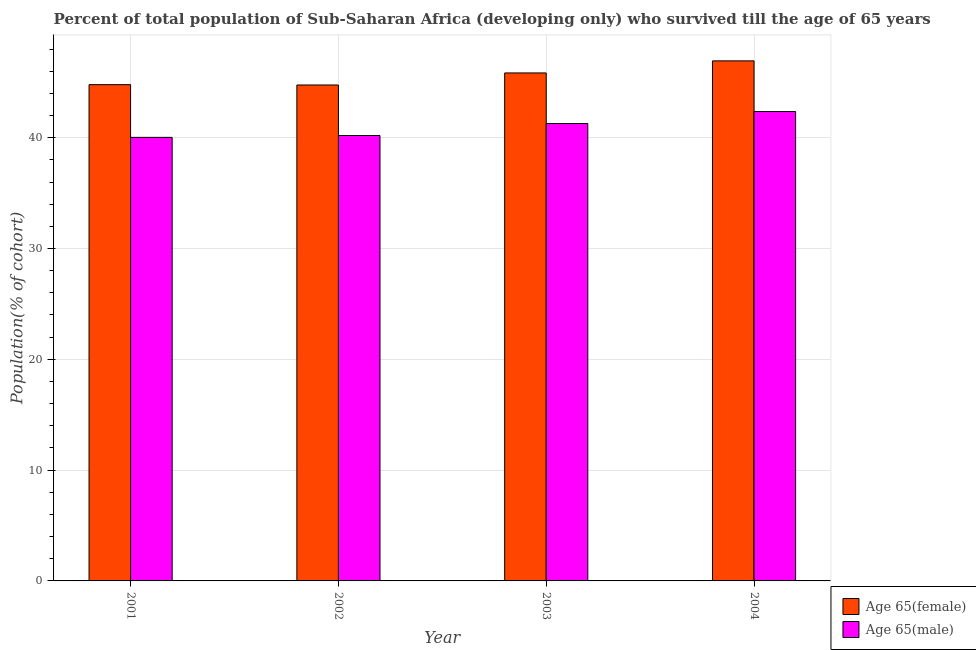Are the number of bars on each tick of the X-axis equal?
Offer a very short reply. Yes. How many bars are there on the 3rd tick from the left?
Your answer should be compact. 2. How many bars are there on the 4th tick from the right?
Your answer should be compact. 2. What is the label of the 4th group of bars from the left?
Offer a terse response. 2004. What is the percentage of female population who survived till age of 65 in 2004?
Provide a short and direct response. 46.93. Across all years, what is the maximum percentage of female population who survived till age of 65?
Offer a terse response. 46.93. Across all years, what is the minimum percentage of male population who survived till age of 65?
Your answer should be very brief. 40.03. What is the total percentage of female population who survived till age of 65 in the graph?
Offer a terse response. 182.32. What is the difference between the percentage of female population who survived till age of 65 in 2003 and that in 2004?
Make the answer very short. -1.09. What is the difference between the percentage of female population who survived till age of 65 in 2003 and the percentage of male population who survived till age of 65 in 2004?
Provide a short and direct response. -1.09. What is the average percentage of female population who survived till age of 65 per year?
Your answer should be compact. 45.58. In the year 2003, what is the difference between the percentage of female population who survived till age of 65 and percentage of male population who survived till age of 65?
Keep it short and to the point. 0. In how many years, is the percentage of male population who survived till age of 65 greater than 10 %?
Your answer should be very brief. 4. What is the ratio of the percentage of male population who survived till age of 65 in 2003 to that in 2004?
Provide a succinct answer. 0.97. Is the difference between the percentage of male population who survived till age of 65 in 2003 and 2004 greater than the difference between the percentage of female population who survived till age of 65 in 2003 and 2004?
Provide a succinct answer. No. What is the difference between the highest and the second highest percentage of male population who survived till age of 65?
Your response must be concise. 1.08. What is the difference between the highest and the lowest percentage of male population who survived till age of 65?
Provide a short and direct response. 2.33. Is the sum of the percentage of female population who survived till age of 65 in 2002 and 2004 greater than the maximum percentage of male population who survived till age of 65 across all years?
Provide a short and direct response. Yes. What does the 2nd bar from the left in 2004 represents?
Your answer should be compact. Age 65(male). What does the 2nd bar from the right in 2003 represents?
Your answer should be very brief. Age 65(female). How many years are there in the graph?
Your response must be concise. 4. Are the values on the major ticks of Y-axis written in scientific E-notation?
Your answer should be compact. No. Does the graph contain grids?
Provide a short and direct response. Yes. Where does the legend appear in the graph?
Your answer should be very brief. Bottom right. How are the legend labels stacked?
Give a very brief answer. Vertical. What is the title of the graph?
Your response must be concise. Percent of total population of Sub-Saharan Africa (developing only) who survived till the age of 65 years. What is the label or title of the Y-axis?
Ensure brevity in your answer.  Population(% of cohort). What is the Population(% of cohort) in Age 65(female) in 2001?
Your response must be concise. 44.79. What is the Population(% of cohort) in Age 65(male) in 2001?
Your answer should be compact. 40.03. What is the Population(% of cohort) of Age 65(female) in 2002?
Keep it short and to the point. 44.76. What is the Population(% of cohort) in Age 65(male) in 2002?
Your answer should be very brief. 40.2. What is the Population(% of cohort) of Age 65(female) in 2003?
Your answer should be compact. 45.84. What is the Population(% of cohort) in Age 65(male) in 2003?
Offer a terse response. 41.28. What is the Population(% of cohort) in Age 65(female) in 2004?
Offer a very short reply. 46.93. What is the Population(% of cohort) in Age 65(male) in 2004?
Keep it short and to the point. 42.36. Across all years, what is the maximum Population(% of cohort) in Age 65(female)?
Provide a short and direct response. 46.93. Across all years, what is the maximum Population(% of cohort) of Age 65(male)?
Provide a succinct answer. 42.36. Across all years, what is the minimum Population(% of cohort) of Age 65(female)?
Provide a succinct answer. 44.76. Across all years, what is the minimum Population(% of cohort) in Age 65(male)?
Provide a short and direct response. 40.03. What is the total Population(% of cohort) in Age 65(female) in the graph?
Keep it short and to the point. 182.32. What is the total Population(% of cohort) of Age 65(male) in the graph?
Give a very brief answer. 163.87. What is the difference between the Population(% of cohort) in Age 65(female) in 2001 and that in 2002?
Provide a succinct answer. 0.03. What is the difference between the Population(% of cohort) in Age 65(male) in 2001 and that in 2002?
Ensure brevity in your answer.  -0.17. What is the difference between the Population(% of cohort) of Age 65(female) in 2001 and that in 2003?
Offer a very short reply. -1.06. What is the difference between the Population(% of cohort) in Age 65(male) in 2001 and that in 2003?
Your response must be concise. -1.25. What is the difference between the Population(% of cohort) of Age 65(female) in 2001 and that in 2004?
Your answer should be compact. -2.15. What is the difference between the Population(% of cohort) in Age 65(male) in 2001 and that in 2004?
Your response must be concise. -2.33. What is the difference between the Population(% of cohort) in Age 65(female) in 2002 and that in 2003?
Your answer should be very brief. -1.09. What is the difference between the Population(% of cohort) in Age 65(male) in 2002 and that in 2003?
Provide a succinct answer. -1.08. What is the difference between the Population(% of cohort) in Age 65(female) in 2002 and that in 2004?
Offer a very short reply. -2.18. What is the difference between the Population(% of cohort) in Age 65(male) in 2002 and that in 2004?
Your answer should be compact. -2.16. What is the difference between the Population(% of cohort) in Age 65(female) in 2003 and that in 2004?
Keep it short and to the point. -1.09. What is the difference between the Population(% of cohort) in Age 65(male) in 2003 and that in 2004?
Your answer should be very brief. -1.08. What is the difference between the Population(% of cohort) in Age 65(female) in 2001 and the Population(% of cohort) in Age 65(male) in 2002?
Offer a very short reply. 4.59. What is the difference between the Population(% of cohort) of Age 65(female) in 2001 and the Population(% of cohort) of Age 65(male) in 2003?
Your answer should be very brief. 3.51. What is the difference between the Population(% of cohort) of Age 65(female) in 2001 and the Population(% of cohort) of Age 65(male) in 2004?
Your response must be concise. 2.43. What is the difference between the Population(% of cohort) of Age 65(female) in 2002 and the Population(% of cohort) of Age 65(male) in 2003?
Your answer should be very brief. 3.48. What is the difference between the Population(% of cohort) of Age 65(female) in 2002 and the Population(% of cohort) of Age 65(male) in 2004?
Your answer should be very brief. 2.4. What is the difference between the Population(% of cohort) in Age 65(female) in 2003 and the Population(% of cohort) in Age 65(male) in 2004?
Provide a succinct answer. 3.48. What is the average Population(% of cohort) of Age 65(female) per year?
Offer a very short reply. 45.58. What is the average Population(% of cohort) in Age 65(male) per year?
Offer a terse response. 40.97. In the year 2001, what is the difference between the Population(% of cohort) in Age 65(female) and Population(% of cohort) in Age 65(male)?
Your answer should be compact. 4.76. In the year 2002, what is the difference between the Population(% of cohort) in Age 65(female) and Population(% of cohort) in Age 65(male)?
Provide a short and direct response. 4.56. In the year 2003, what is the difference between the Population(% of cohort) of Age 65(female) and Population(% of cohort) of Age 65(male)?
Your response must be concise. 4.57. In the year 2004, what is the difference between the Population(% of cohort) of Age 65(female) and Population(% of cohort) of Age 65(male)?
Your answer should be very brief. 4.57. What is the ratio of the Population(% of cohort) of Age 65(female) in 2001 to that in 2002?
Provide a succinct answer. 1. What is the ratio of the Population(% of cohort) of Age 65(male) in 2001 to that in 2002?
Give a very brief answer. 1. What is the ratio of the Population(% of cohort) in Age 65(male) in 2001 to that in 2003?
Give a very brief answer. 0.97. What is the ratio of the Population(% of cohort) of Age 65(female) in 2001 to that in 2004?
Offer a very short reply. 0.95. What is the ratio of the Population(% of cohort) in Age 65(male) in 2001 to that in 2004?
Provide a succinct answer. 0.94. What is the ratio of the Population(% of cohort) in Age 65(female) in 2002 to that in 2003?
Make the answer very short. 0.98. What is the ratio of the Population(% of cohort) in Age 65(male) in 2002 to that in 2003?
Keep it short and to the point. 0.97. What is the ratio of the Population(% of cohort) of Age 65(female) in 2002 to that in 2004?
Offer a very short reply. 0.95. What is the ratio of the Population(% of cohort) in Age 65(male) in 2002 to that in 2004?
Your answer should be compact. 0.95. What is the ratio of the Population(% of cohort) of Age 65(female) in 2003 to that in 2004?
Keep it short and to the point. 0.98. What is the ratio of the Population(% of cohort) in Age 65(male) in 2003 to that in 2004?
Provide a succinct answer. 0.97. What is the difference between the highest and the second highest Population(% of cohort) in Age 65(female)?
Your response must be concise. 1.09. What is the difference between the highest and the second highest Population(% of cohort) in Age 65(male)?
Your answer should be very brief. 1.08. What is the difference between the highest and the lowest Population(% of cohort) in Age 65(female)?
Ensure brevity in your answer.  2.18. What is the difference between the highest and the lowest Population(% of cohort) in Age 65(male)?
Provide a succinct answer. 2.33. 